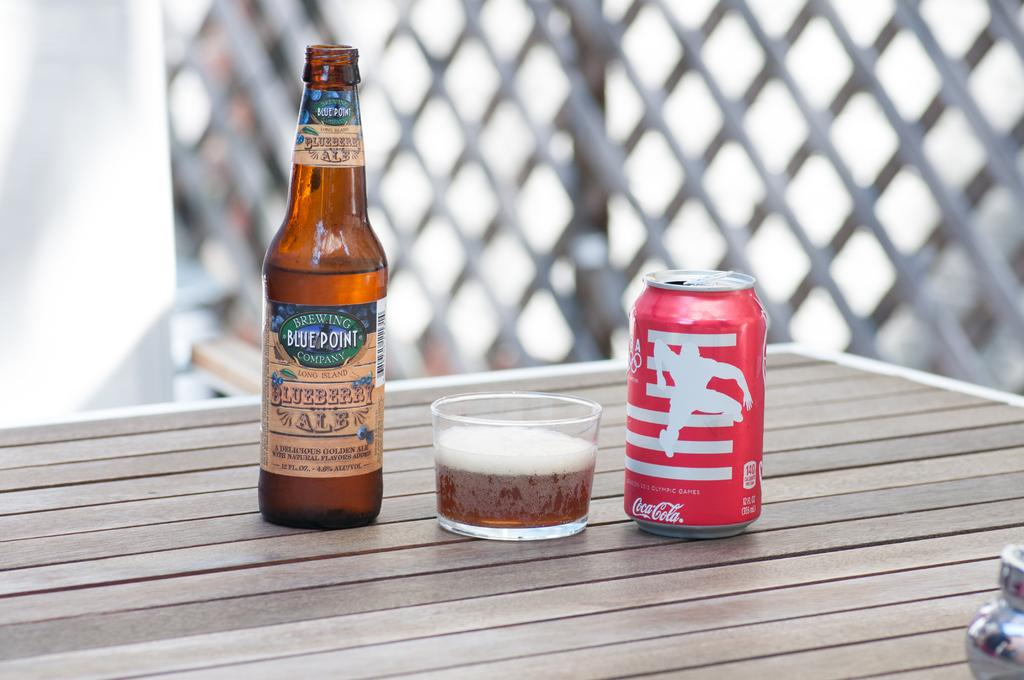<image>
Share a concise interpretation of the image provided. A wooden table has a bottle of Blue Point beer on it with a glass and a can of Coca-cola. 